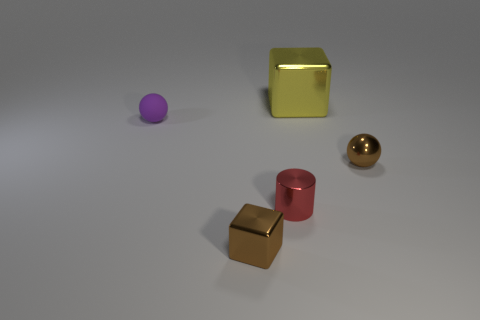How many red metallic things are the same size as the yellow metallic thing?
Provide a succinct answer. 0. The block that is the same color as the small metal ball is what size?
Provide a succinct answer. Small. How many objects are either yellow cylinders or metallic things behind the red metal object?
Give a very brief answer. 2. There is a small thing that is both in front of the small brown sphere and to the left of the tiny red shiny object; what color is it?
Provide a succinct answer. Brown. Is the rubber object the same size as the yellow thing?
Offer a terse response. No. What is the color of the tiny sphere that is to the left of the yellow metal cube?
Your response must be concise. Purple. Are there any small cubes of the same color as the large shiny thing?
Provide a succinct answer. No. What color is the matte ball that is the same size as the brown block?
Provide a short and direct response. Purple. Does the red shiny thing have the same shape as the big yellow metal object?
Provide a short and direct response. No. What is the tiny sphere that is in front of the small matte sphere made of?
Your answer should be very brief. Metal. 